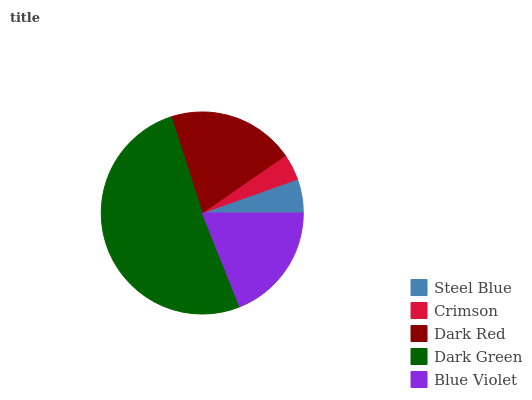Is Crimson the minimum?
Answer yes or no. Yes. Is Dark Green the maximum?
Answer yes or no. Yes. Is Dark Red the minimum?
Answer yes or no. No. Is Dark Red the maximum?
Answer yes or no. No. Is Dark Red greater than Crimson?
Answer yes or no. Yes. Is Crimson less than Dark Red?
Answer yes or no. Yes. Is Crimson greater than Dark Red?
Answer yes or no. No. Is Dark Red less than Crimson?
Answer yes or no. No. Is Blue Violet the high median?
Answer yes or no. Yes. Is Blue Violet the low median?
Answer yes or no. Yes. Is Crimson the high median?
Answer yes or no. No. Is Dark Red the low median?
Answer yes or no. No. 